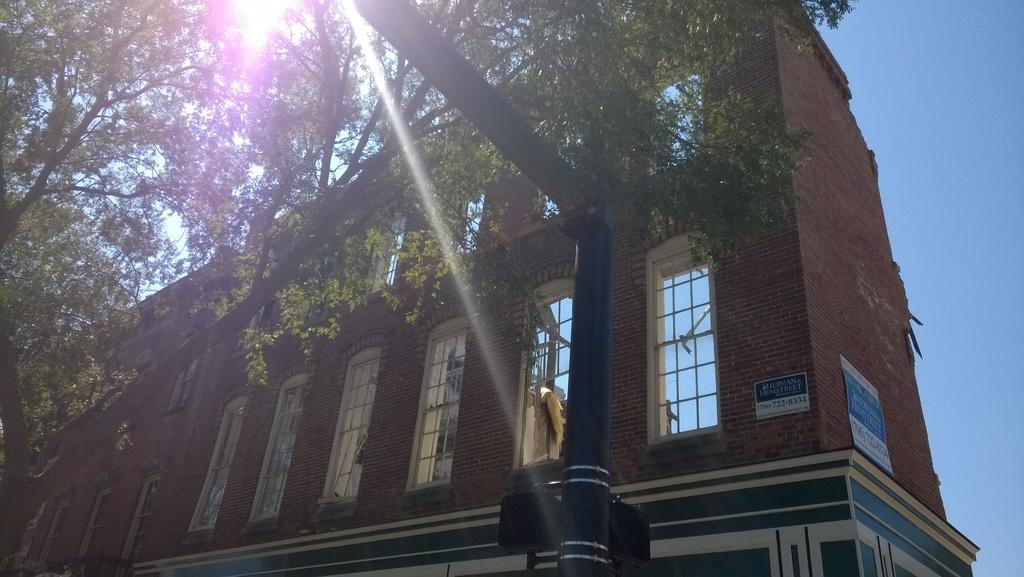What type of structure is present in the image? There is a building in the image. What feature of the building is mentioned in the facts? The building has windows. What natural element can be seen in the image? There is a tree with branches and leaves in the image. What type of signage is present in the image? There are posters with text in the image. What other object can be seen in the image? There is a pole in the image. What part of the environment is visible in the image? The sky is visible in the image. What is the weight of the ink used on the posters in the image? There is no information about the weight of the ink used on the posters in the image, nor is there any indication that ink is present. What type of minister is depicted in the image? There is no minister present in the image. 